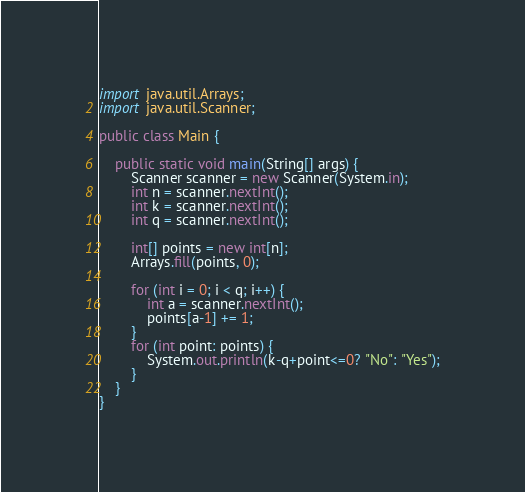<code> <loc_0><loc_0><loc_500><loc_500><_Java_>import java.util.Arrays;
import java.util.Scanner;

public class Main {

    public static void main(String[] args) {
        Scanner scanner = new Scanner(System.in);
        int n = scanner.nextInt();
        int k = scanner.nextInt();
        int q = scanner.nextInt();

        int[] points = new int[n];
        Arrays.fill(points, 0);

        for (int i = 0; i < q; i++) {
            int a = scanner.nextInt();
            points[a-1] += 1;
        }
        for (int point: points) {
            System.out.println(k-q+point<=0? "No": "Yes");
        }
    }
}</code> 